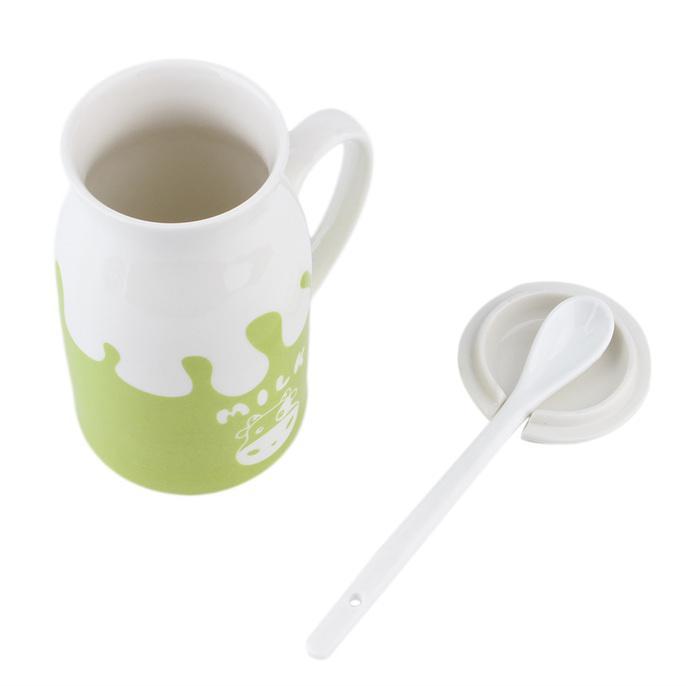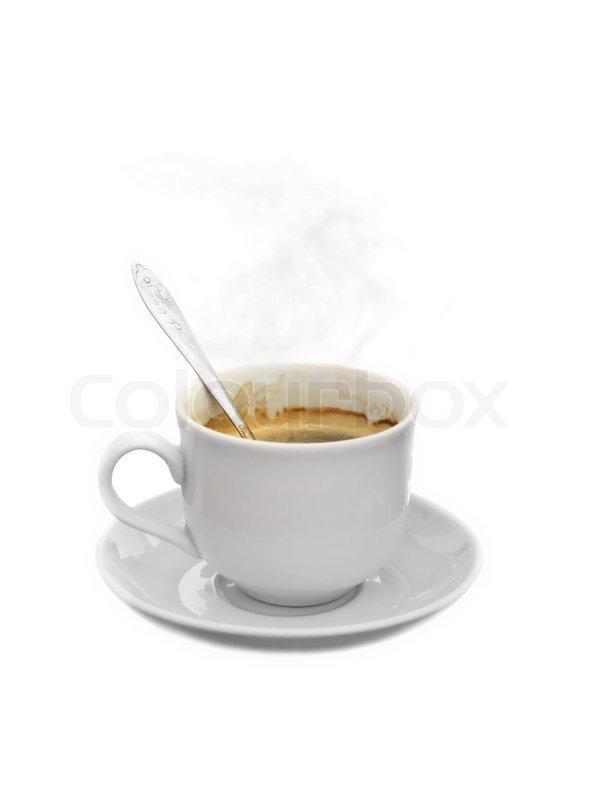The first image is the image on the left, the second image is the image on the right. Examine the images to the left and right. Is the description "There are three or more tea cups." accurate? Answer yes or no. No. The first image is the image on the left, the second image is the image on the right. For the images displayed, is the sentence "A spoon is resting on a saucer near a tea cup." factually correct? Answer yes or no. No. 